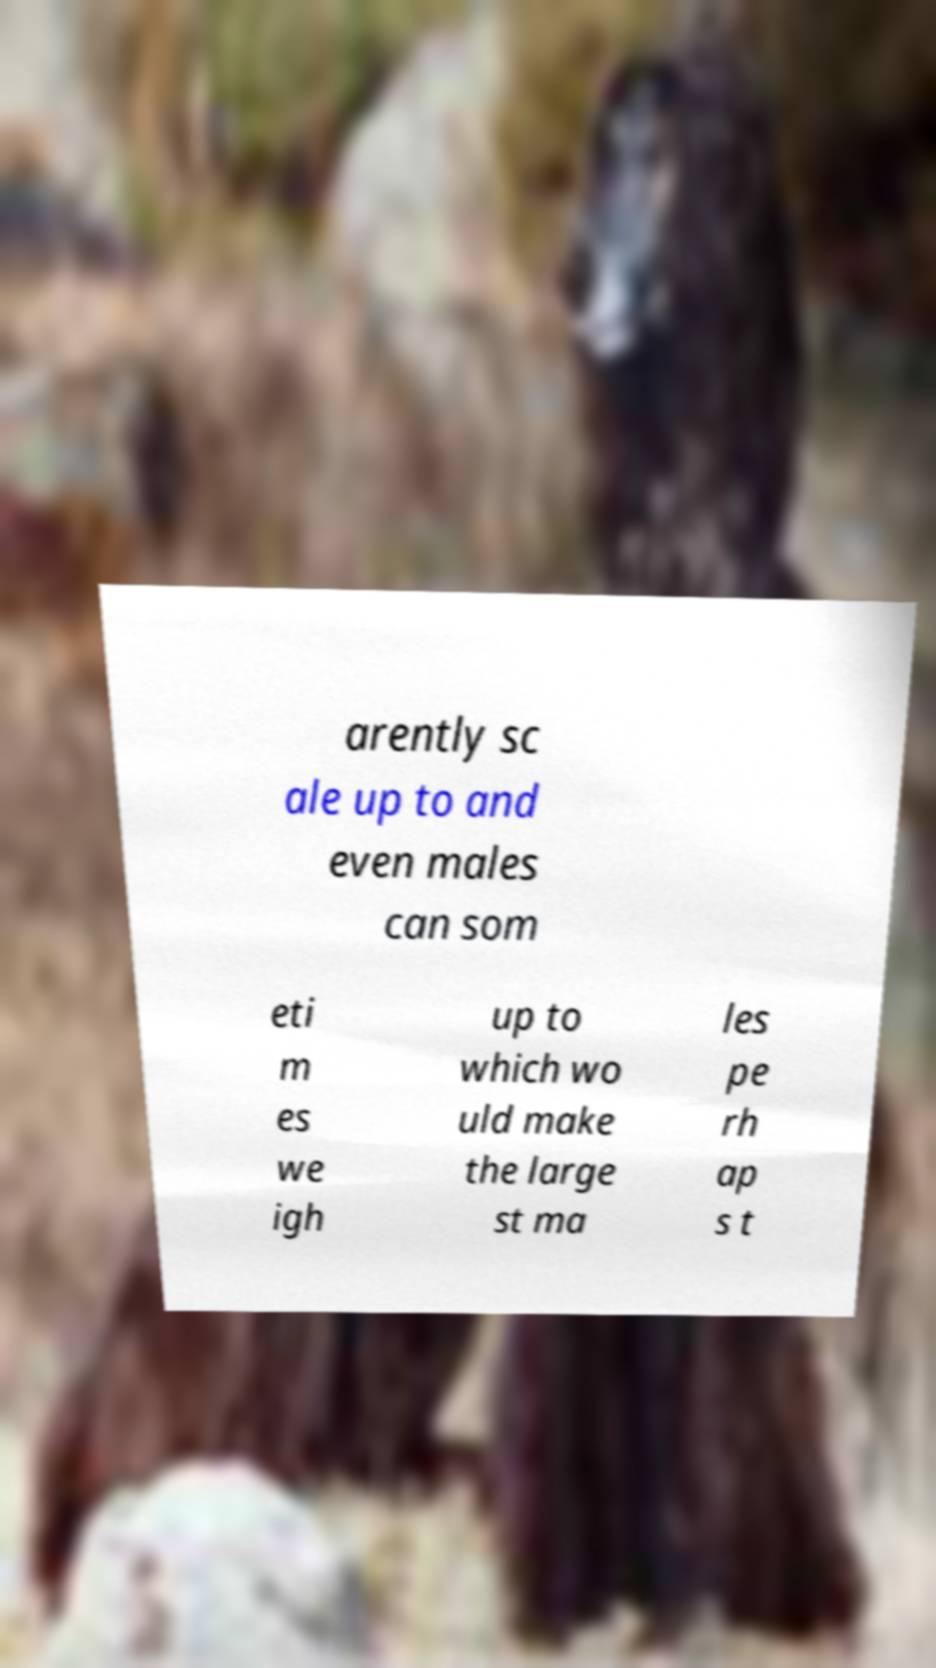For documentation purposes, I need the text within this image transcribed. Could you provide that? arently sc ale up to and even males can som eti m es we igh up to which wo uld make the large st ma les pe rh ap s t 